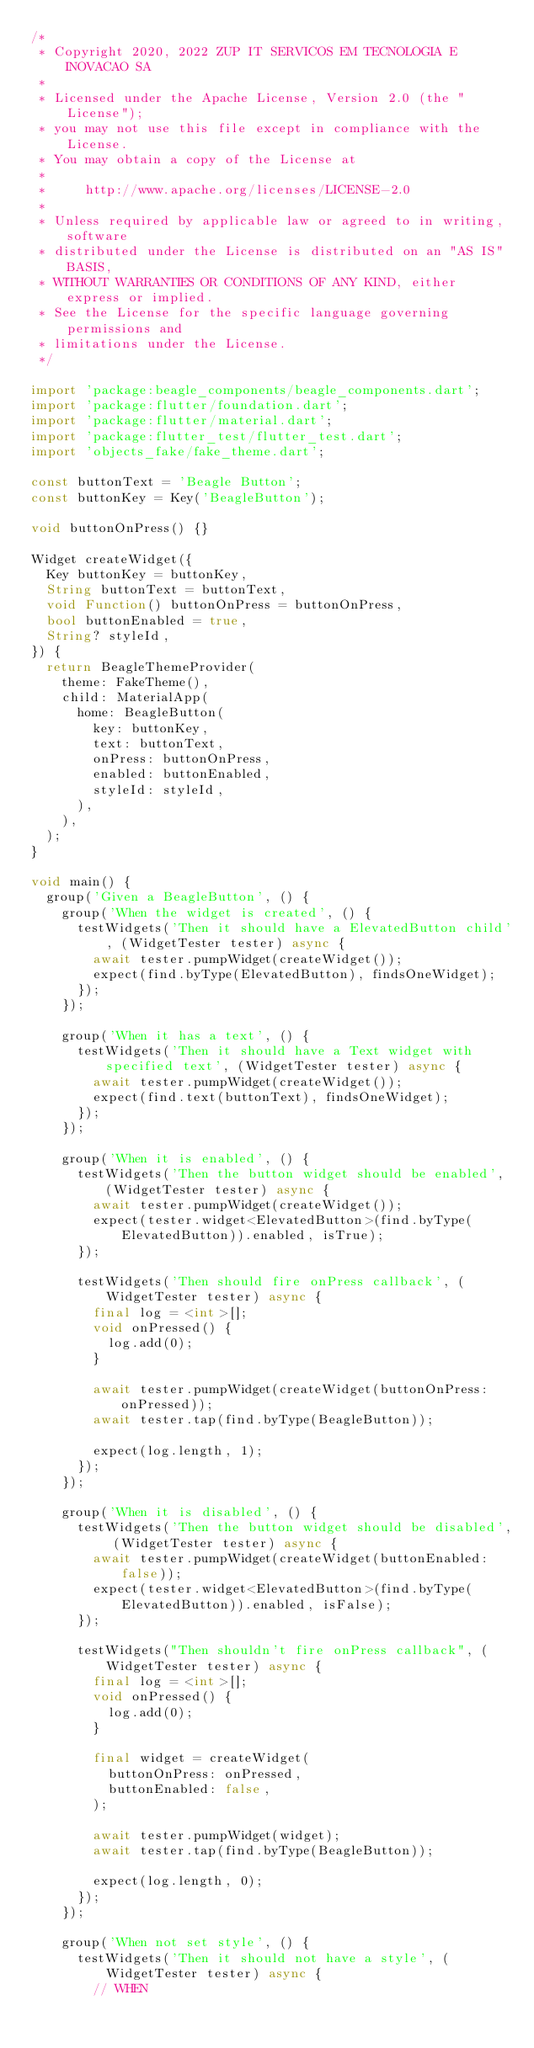Convert code to text. <code><loc_0><loc_0><loc_500><loc_500><_Dart_>/*
 * Copyright 2020, 2022 ZUP IT SERVICOS EM TECNOLOGIA E INOVACAO SA
 *
 * Licensed under the Apache License, Version 2.0 (the "License");
 * you may not use this file except in compliance with the License.
 * You may obtain a copy of the License at
 *
 *     http://www.apache.org/licenses/LICENSE-2.0
 *
 * Unless required by applicable law or agreed to in writing, software
 * distributed under the License is distributed on an "AS IS" BASIS,
 * WITHOUT WARRANTIES OR CONDITIONS OF ANY KIND, either express or implied.
 * See the License for the specific language governing permissions and
 * limitations under the License.
 */

import 'package:beagle_components/beagle_components.dart';
import 'package:flutter/foundation.dart';
import 'package:flutter/material.dart';
import 'package:flutter_test/flutter_test.dart';
import 'objects_fake/fake_theme.dart';

const buttonText = 'Beagle Button';
const buttonKey = Key('BeagleButton');

void buttonOnPress() {}

Widget createWidget({
  Key buttonKey = buttonKey,
  String buttonText = buttonText,
  void Function() buttonOnPress = buttonOnPress,
  bool buttonEnabled = true,
  String? styleId,
}) {
  return BeagleThemeProvider(
    theme: FakeTheme(),
    child: MaterialApp(
      home: BeagleButton(
        key: buttonKey,
        text: buttonText,
        onPress: buttonOnPress,
        enabled: buttonEnabled,
        styleId: styleId,
      ),
    ),
  );
}

void main() {
  group('Given a BeagleButton', () {
    group('When the widget is created', () {
      testWidgets('Then it should have a ElevatedButton child', (WidgetTester tester) async {
        await tester.pumpWidget(createWidget());
        expect(find.byType(ElevatedButton), findsOneWidget);
      });
    });

    group('When it has a text', () {
      testWidgets('Then it should have a Text widget with specified text', (WidgetTester tester) async {
        await tester.pumpWidget(createWidget());
        expect(find.text(buttonText), findsOneWidget);
      });
    });

    group('When it is enabled', () {
      testWidgets('Then the button widget should be enabled', (WidgetTester tester) async {
        await tester.pumpWidget(createWidget());
        expect(tester.widget<ElevatedButton>(find.byType(ElevatedButton)).enabled, isTrue);
      });

      testWidgets('Then should fire onPress callback', (WidgetTester tester) async {
        final log = <int>[];
        void onPressed() {
          log.add(0);
        }

        await tester.pumpWidget(createWidget(buttonOnPress: onPressed));
        await tester.tap(find.byType(BeagleButton));

        expect(log.length, 1);
      });
    });

    group('When it is disabled', () {
      testWidgets('Then the button widget should be disabled', (WidgetTester tester) async {
        await tester.pumpWidget(createWidget(buttonEnabled: false));
        expect(tester.widget<ElevatedButton>(find.byType(ElevatedButton)).enabled, isFalse);
      });

      testWidgets("Then shouldn't fire onPress callback", (WidgetTester tester) async {
        final log = <int>[];
        void onPressed() {
          log.add(0);
        }

        final widget = createWidget(
          buttonOnPress: onPressed,
          buttonEnabled: false,
        );

        await tester.pumpWidget(widget);
        await tester.tap(find.byType(BeagleButton));

        expect(log.length, 0);
      });
    });

    group('When not set style', () {
      testWidgets('Then it should not have a style', (WidgetTester tester) async {
        // WHEN</code> 